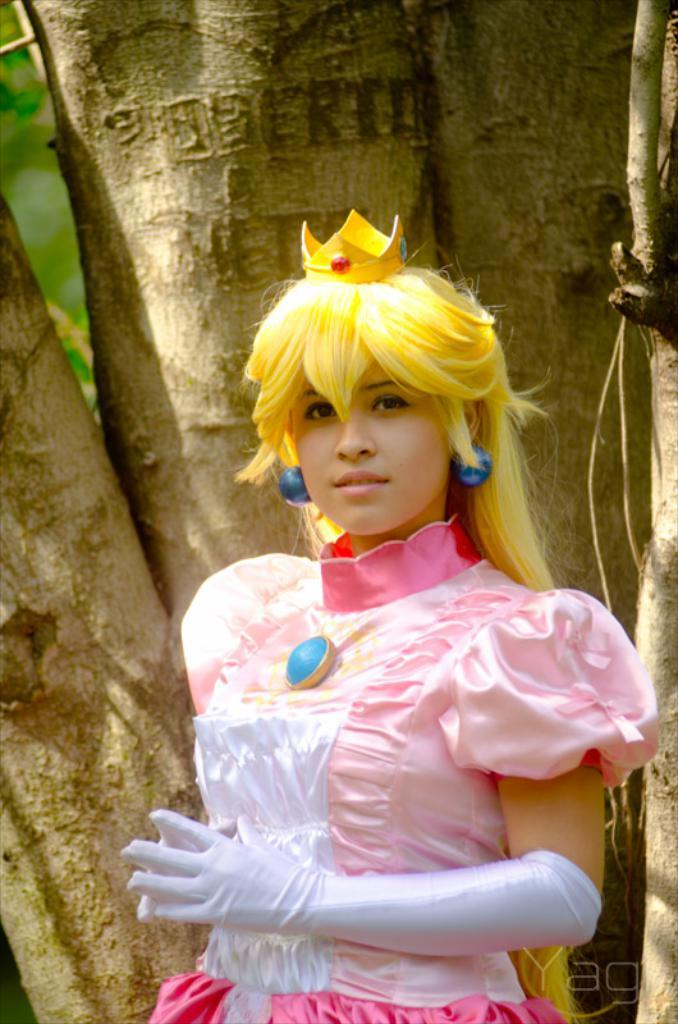Who is present in the image? There are women in the image. What are the women wearing on their hands? The women are wearing hand gloves. What can be seen in the background of the image? There are barks of a tree in the background of the image. Where is the text located in the image? The text is visible in the bottom right corner of the image. What type of pig can be seen in the image? There is no pig present in the image. What note is the woman holding in the image? There is no note visible in the image. 